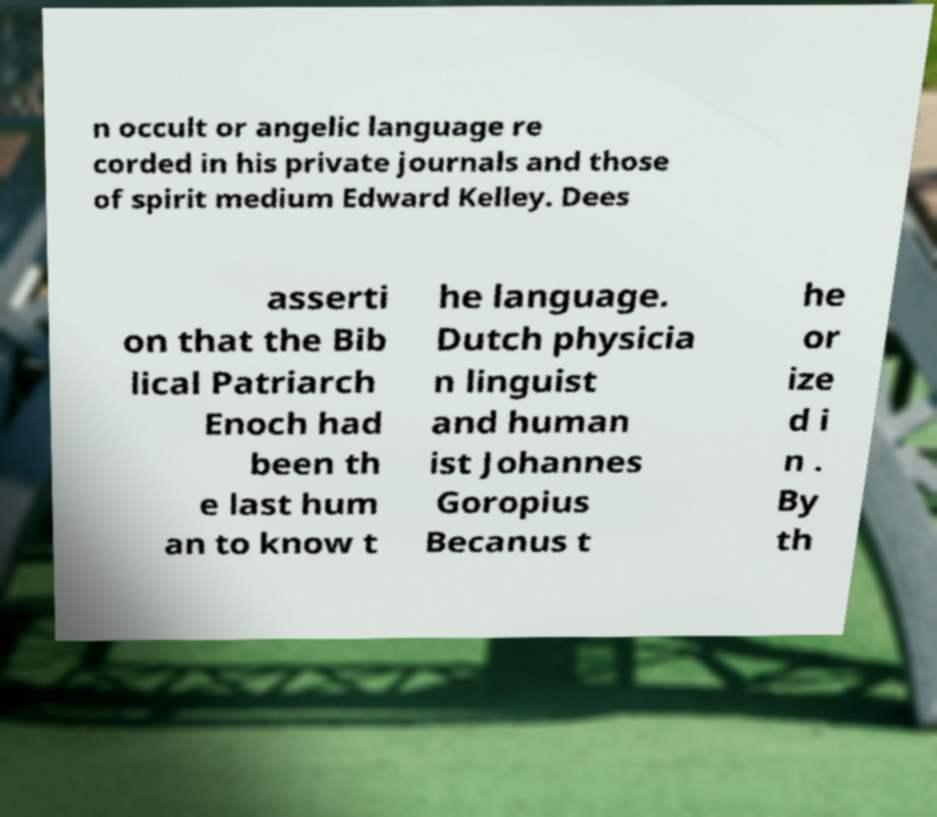What messages or text are displayed in this image? I need them in a readable, typed format. n occult or angelic language re corded in his private journals and those of spirit medium Edward Kelley. Dees asserti on that the Bib lical Patriarch Enoch had been th e last hum an to know t he language. Dutch physicia n linguist and human ist Johannes Goropius Becanus t he or ize d i n . By th 